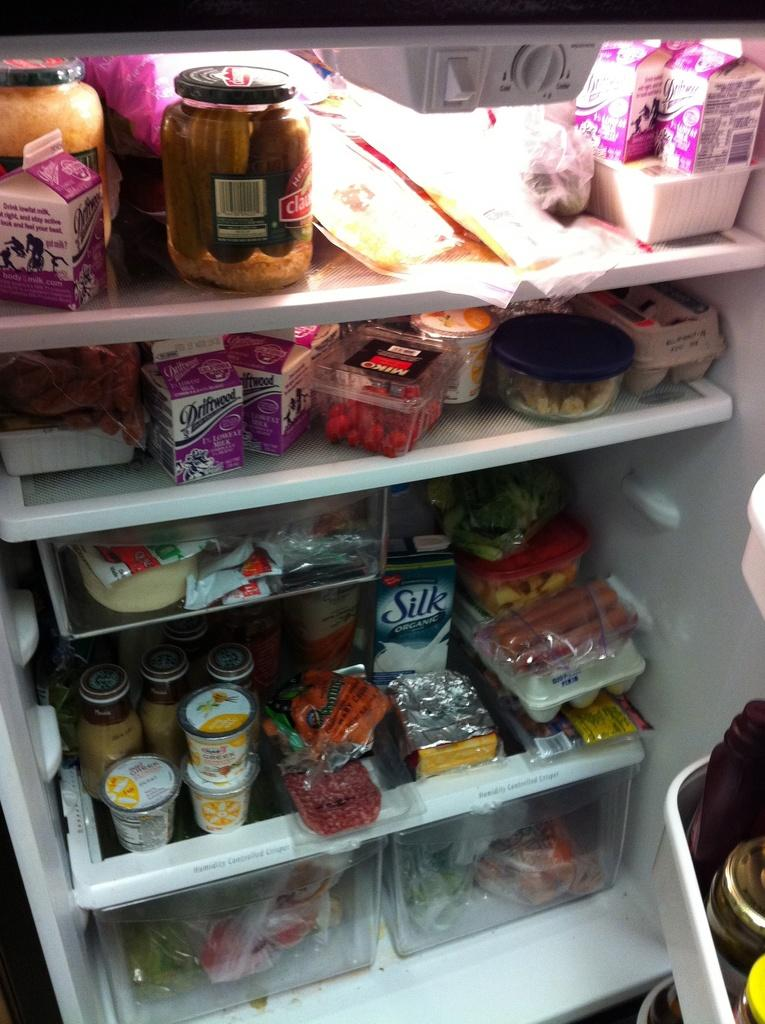<image>
Provide a brief description of the given image. A refrigerator full of all kinds of food, including Driftwood 1% lowfat milk. 